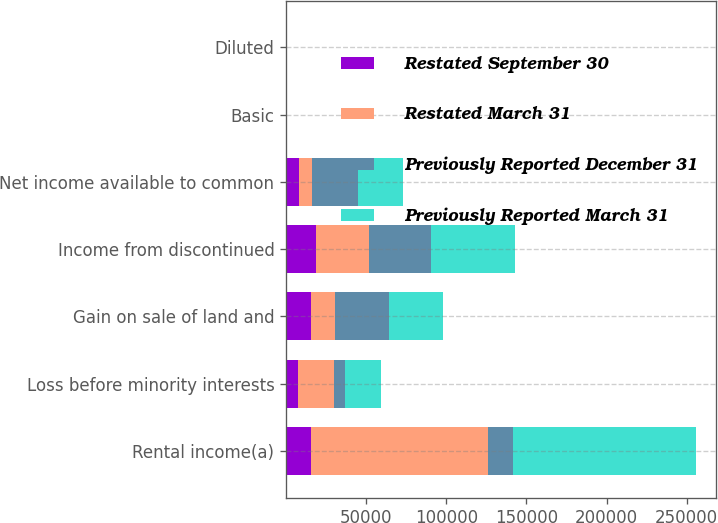Convert chart to OTSL. <chart><loc_0><loc_0><loc_500><loc_500><stacked_bar_chart><ecel><fcel>Rental income(a)<fcel>Loss before minority interests<fcel>Gain on sale of land and<fcel>Income from discontinued<fcel>Net income available to common<fcel>Basic<fcel>Diluted<nl><fcel>Restated September 30<fcel>15347<fcel>7193<fcel>15347<fcel>18550<fcel>8165<fcel>0.06<fcel>0.06<nl><fcel>Restated March 31<fcel>110954<fcel>22707<fcel>15347<fcel>33123<fcel>8165<fcel>0.06<fcel>0.06<nl><fcel>Previously Reported December 31<fcel>15347<fcel>6986<fcel>33482<fcel>38545<fcel>28342<fcel>0.21<fcel>0.21<nl><fcel>Previously Reported March 31<fcel>114025<fcel>22276<fcel>33482<fcel>52923<fcel>28342<fcel>0.21<fcel>0.21<nl></chart> 